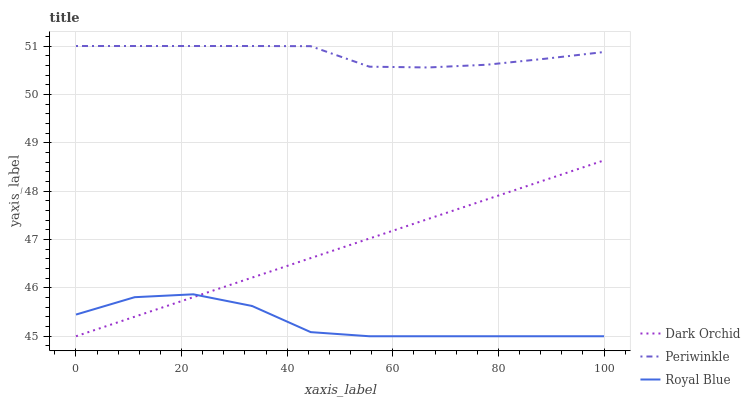Does Royal Blue have the minimum area under the curve?
Answer yes or no. Yes. Does Periwinkle have the maximum area under the curve?
Answer yes or no. Yes. Does Dark Orchid have the minimum area under the curve?
Answer yes or no. No. Does Dark Orchid have the maximum area under the curve?
Answer yes or no. No. Is Dark Orchid the smoothest?
Answer yes or no. Yes. Is Royal Blue the roughest?
Answer yes or no. Yes. Is Periwinkle the smoothest?
Answer yes or no. No. Is Periwinkle the roughest?
Answer yes or no. No. Does Periwinkle have the lowest value?
Answer yes or no. No. Does Periwinkle have the highest value?
Answer yes or no. Yes. Does Dark Orchid have the highest value?
Answer yes or no. No. Is Dark Orchid less than Periwinkle?
Answer yes or no. Yes. Is Periwinkle greater than Dark Orchid?
Answer yes or no. Yes. Does Dark Orchid intersect Periwinkle?
Answer yes or no. No. 